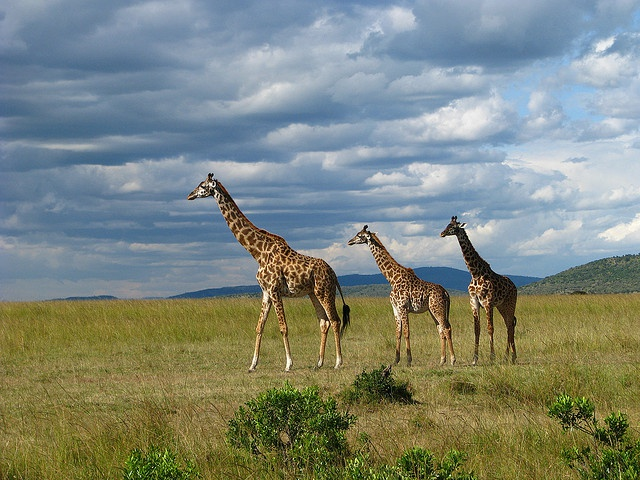Describe the objects in this image and their specific colors. I can see giraffe in darkgray, black, olive, maroon, and tan tones, giraffe in darkgray, black, maroon, and tan tones, and giraffe in darkgray, black, maroon, olive, and tan tones in this image. 